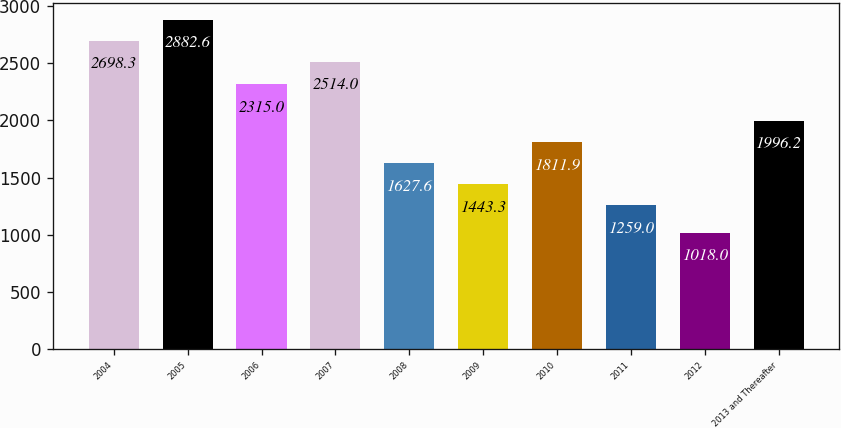Convert chart. <chart><loc_0><loc_0><loc_500><loc_500><bar_chart><fcel>2004<fcel>2005<fcel>2006<fcel>2007<fcel>2008<fcel>2009<fcel>2010<fcel>2011<fcel>2012<fcel>2013 and Thereafter<nl><fcel>2698.3<fcel>2882.6<fcel>2315<fcel>2514<fcel>1627.6<fcel>1443.3<fcel>1811.9<fcel>1259<fcel>1018<fcel>1996.2<nl></chart> 